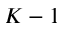Convert formula to latex. <formula><loc_0><loc_0><loc_500><loc_500>K - 1</formula> 